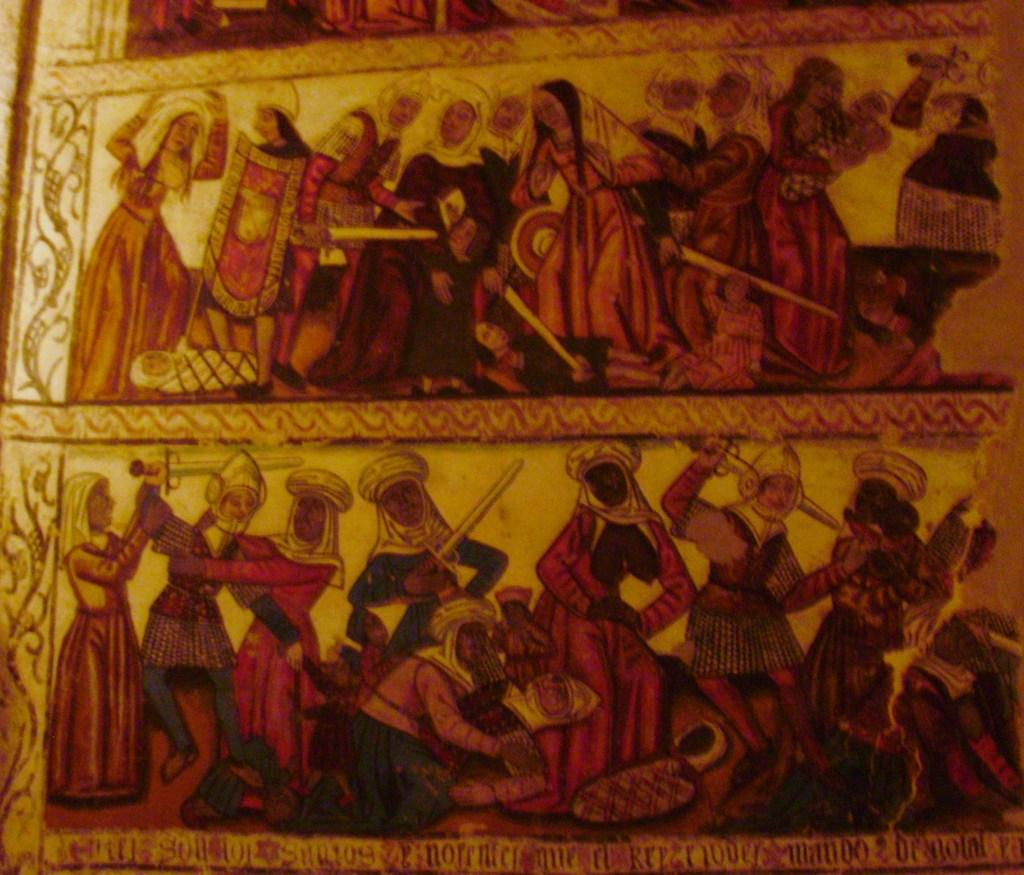What is the main subject of the image? There is a painting in the image. What does the painting depict? The painting depicts people. Are there any other elements in the painting besides the people? Yes, there are other things depicted in the painting. What is the painting placed on or attached to? The painting is on an object. How many dogs are sitting on the sofa in the image? There are no dogs or sofa present in the image; it features a painting of people. 